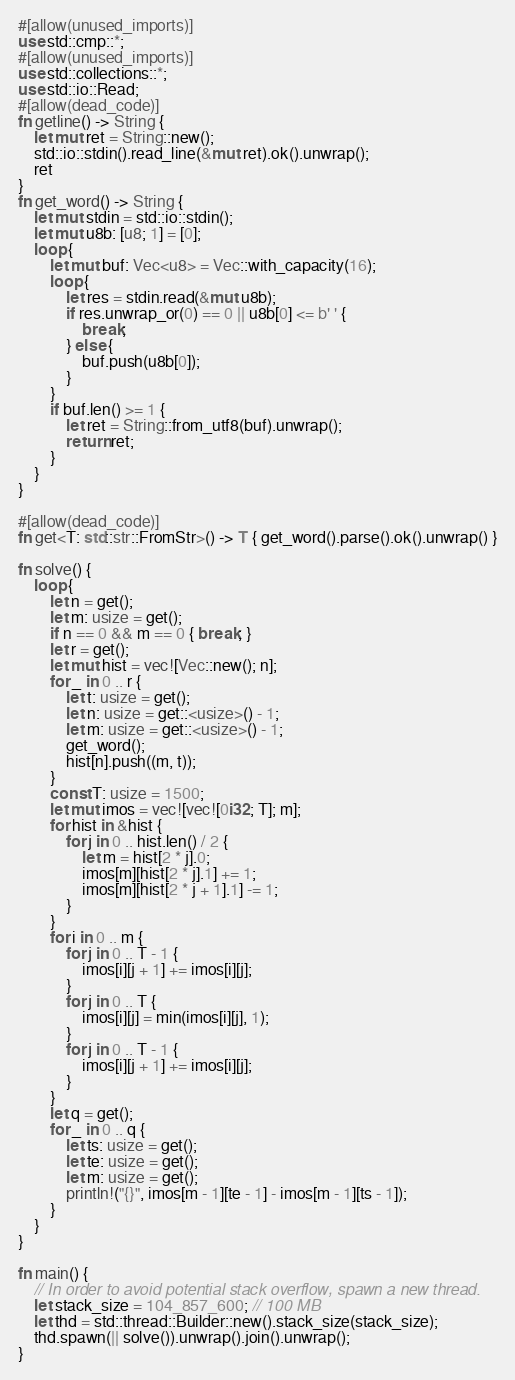Convert code to text. <code><loc_0><loc_0><loc_500><loc_500><_Rust_>#[allow(unused_imports)]
use std::cmp::*;
#[allow(unused_imports)]
use std::collections::*;
use std::io::Read;
#[allow(dead_code)]
fn getline() -> String {
    let mut ret = String::new();
    std::io::stdin().read_line(&mut ret).ok().unwrap();
    ret
}
fn get_word() -> String {
    let mut stdin = std::io::stdin();
    let mut u8b: [u8; 1] = [0];
    loop {
        let mut buf: Vec<u8> = Vec::with_capacity(16);
        loop {
            let res = stdin.read(&mut u8b);
            if res.unwrap_or(0) == 0 || u8b[0] <= b' ' {
                break;
            } else {
                buf.push(u8b[0]);
            }
        }
        if buf.len() >= 1 {
            let ret = String::from_utf8(buf).unwrap();
            return ret;
        }
    }
}

#[allow(dead_code)]
fn get<T: std::str::FromStr>() -> T { get_word().parse().ok().unwrap() }

fn solve() {
    loop {
        let n = get();
        let m: usize = get();
        if n == 0 && m == 0 { break; }
        let r = get();
        let mut hist = vec![Vec::new(); n];
        for _ in 0 .. r {
            let t: usize = get();
            let n: usize = get::<usize>() - 1;
            let m: usize = get::<usize>() - 1;
            get_word();
            hist[n].push((m, t));
        }
        const T: usize = 1500;
        let mut imos = vec![vec![0i32; T]; m];
        for hist in &hist {
            for j in 0 .. hist.len() / 2 {
                let m = hist[2 * j].0;
                imos[m][hist[2 * j].1] += 1;
                imos[m][hist[2 * j + 1].1] -= 1;
            }
        }
        for i in 0 .. m {
            for j in 0 .. T - 1 {
                imos[i][j + 1] += imos[i][j];
            }
            for j in 0 .. T {
                imos[i][j] = min(imos[i][j], 1);
            }
            for j in 0 .. T - 1 {
                imos[i][j + 1] += imos[i][j];
            }
        }
        let q = get();
        for _ in 0 .. q {
            let ts: usize = get();
            let te: usize = get();
            let m: usize = get();
            println!("{}", imos[m - 1][te - 1] - imos[m - 1][ts - 1]);
        }
    }
}

fn main() {
    // In order to avoid potential stack overflow, spawn a new thread.
    let stack_size = 104_857_600; // 100 MB
    let thd = std::thread::Builder::new().stack_size(stack_size);
    thd.spawn(|| solve()).unwrap().join().unwrap();
}

</code> 